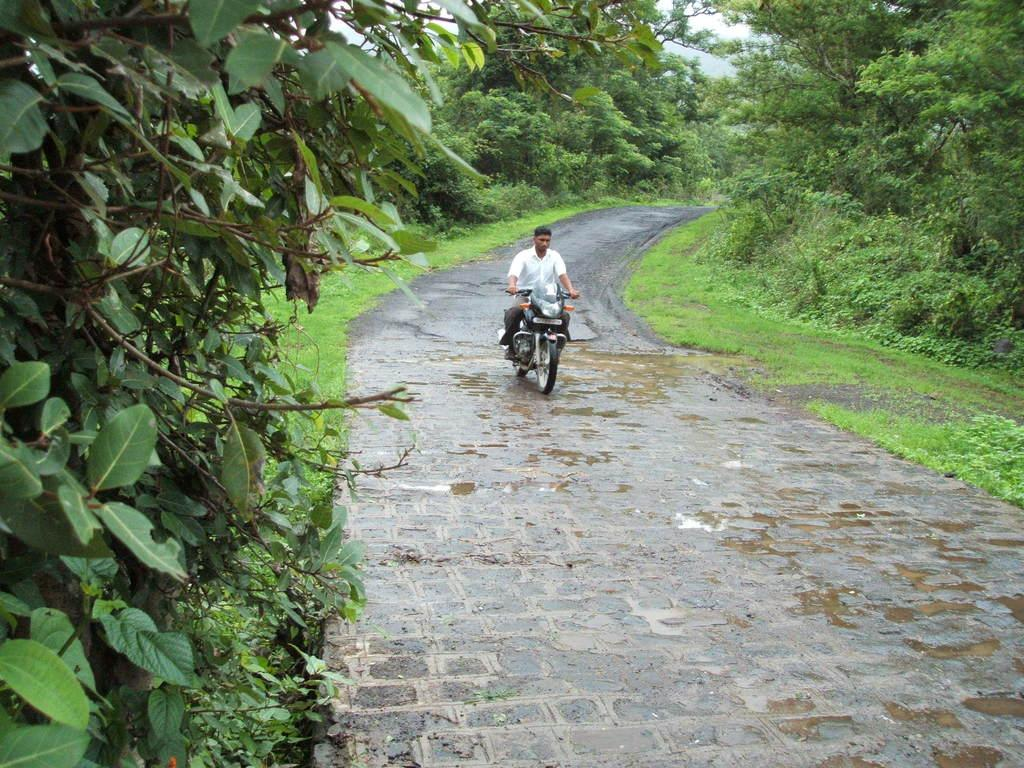What is the man in the image doing? The man is riding a bike in the image. Where is the man located in the image? The man is in the center of the image. What can be seen in the background of the image? There are trees and the sky visible in the background of the image. What is at the bottom of the image? There is a road at the bottom of the image. Can you see any cobwebs on the wall in the image? There is no wall or cobwebs present in the image. What type of amusement can be seen in the image? There is no amusement depicted in the image; it features a man riding a bike on a road with trees and sky in the background. 